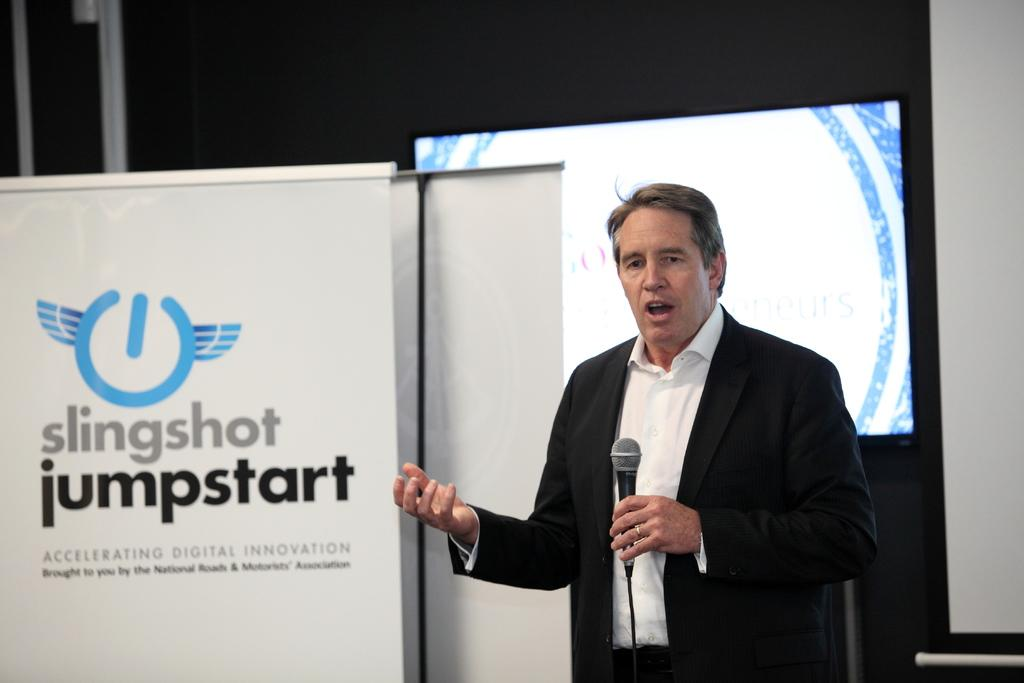Who is the main subject in the image? There is a man in the image. What is the man holding in the image? The man is holding a microphone. What can be seen on the wall in the image? There is a display screen on a wall in the image. What type of structures are visible in the image? There are poles visible in the image. What message or information is conveyed by the banner in the image? There is a banner with text in the image. What hobbies does the pen in the image enjoy? There is no pen present in the image, so it is not possible to determine its hobbies. 